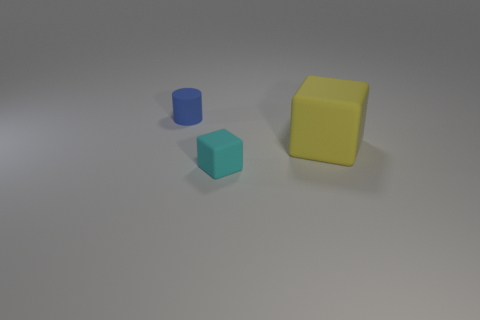How many objects are things right of the tiny cylinder or small things that are on the left side of the tiny matte cube?
Provide a succinct answer. 3. Are there any other things that have the same color as the large cube?
Your answer should be very brief. No. What is the color of the tiny rubber object on the left side of the tiny thing in front of the tiny object left of the tiny block?
Provide a succinct answer. Blue. What size is the matte object that is behind the matte block to the right of the tiny cyan rubber cube?
Your answer should be compact. Small. What is the thing that is in front of the blue matte object and left of the large yellow matte cube made of?
Your response must be concise. Rubber. Does the cyan thing have the same size as the matte thing behind the yellow thing?
Your answer should be very brief. Yes. Is there a small cyan rubber object?
Offer a very short reply. Yes. What is the material of the small object that is the same shape as the large yellow rubber object?
Give a very brief answer. Rubber. There is a blue matte cylinder behind the matte cube left of the block to the right of the cyan matte block; how big is it?
Your answer should be compact. Small. Are there any small cyan matte things on the right side of the cyan thing?
Give a very brief answer. No. 